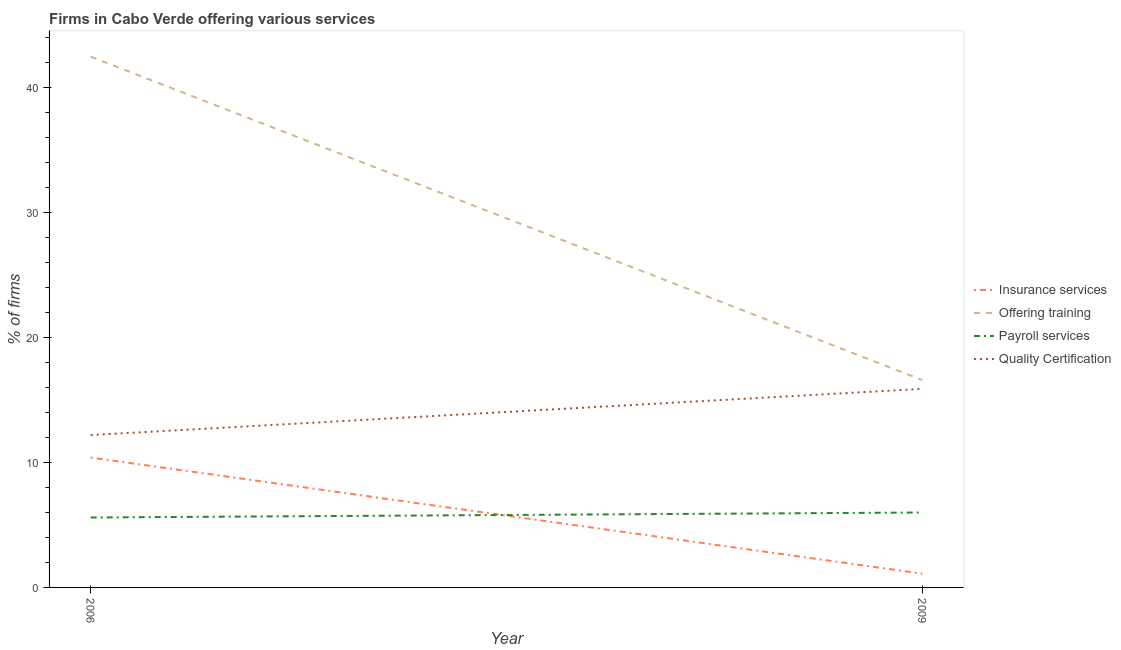Is the number of lines equal to the number of legend labels?
Make the answer very short. Yes. Across all years, what is the maximum percentage of firms offering training?
Give a very brief answer. 42.5. Across all years, what is the minimum percentage of firms offering quality certification?
Ensure brevity in your answer.  12.2. In which year was the percentage of firms offering payroll services maximum?
Your response must be concise. 2009. In which year was the percentage of firms offering payroll services minimum?
Offer a very short reply. 2006. What is the total percentage of firms offering insurance services in the graph?
Offer a very short reply. 11.5. What is the difference between the percentage of firms offering quality certification in 2006 and that in 2009?
Offer a very short reply. -3.7. What is the difference between the percentage of firms offering training in 2009 and the percentage of firms offering quality certification in 2006?
Your answer should be compact. 4.4. What is the average percentage of firms offering payroll services per year?
Make the answer very short. 5.8. In the year 2009, what is the difference between the percentage of firms offering training and percentage of firms offering payroll services?
Ensure brevity in your answer.  10.6. What is the ratio of the percentage of firms offering insurance services in 2006 to that in 2009?
Ensure brevity in your answer.  9.45. Is the percentage of firms offering quality certification in 2006 less than that in 2009?
Provide a succinct answer. Yes. Is it the case that in every year, the sum of the percentage of firms offering quality certification and percentage of firms offering insurance services is greater than the sum of percentage of firms offering training and percentage of firms offering payroll services?
Provide a short and direct response. No. Is it the case that in every year, the sum of the percentage of firms offering insurance services and percentage of firms offering training is greater than the percentage of firms offering payroll services?
Provide a short and direct response. Yes. Is the percentage of firms offering quality certification strictly greater than the percentage of firms offering training over the years?
Provide a succinct answer. No. How many years are there in the graph?
Provide a short and direct response. 2. Are the values on the major ticks of Y-axis written in scientific E-notation?
Your answer should be compact. No. What is the title of the graph?
Ensure brevity in your answer.  Firms in Cabo Verde offering various services . Does "Social equity" appear as one of the legend labels in the graph?
Your answer should be very brief. No. What is the label or title of the X-axis?
Your answer should be very brief. Year. What is the label or title of the Y-axis?
Make the answer very short. % of firms. What is the % of firms in Offering training in 2006?
Provide a succinct answer. 42.5. What is the % of firms in Quality Certification in 2009?
Give a very brief answer. 15.9. Across all years, what is the maximum % of firms in Insurance services?
Keep it short and to the point. 10.4. Across all years, what is the maximum % of firms of Offering training?
Ensure brevity in your answer.  42.5. Across all years, what is the maximum % of firms of Quality Certification?
Ensure brevity in your answer.  15.9. Across all years, what is the minimum % of firms of Insurance services?
Provide a succinct answer. 1.1. Across all years, what is the minimum % of firms of Offering training?
Give a very brief answer. 16.6. Across all years, what is the minimum % of firms in Quality Certification?
Give a very brief answer. 12.2. What is the total % of firms in Insurance services in the graph?
Your answer should be very brief. 11.5. What is the total % of firms of Offering training in the graph?
Offer a very short reply. 59.1. What is the total % of firms in Payroll services in the graph?
Provide a succinct answer. 11.6. What is the total % of firms in Quality Certification in the graph?
Offer a terse response. 28.1. What is the difference between the % of firms in Insurance services in 2006 and that in 2009?
Keep it short and to the point. 9.3. What is the difference between the % of firms of Offering training in 2006 and that in 2009?
Make the answer very short. 25.9. What is the difference between the % of firms in Payroll services in 2006 and that in 2009?
Your answer should be very brief. -0.4. What is the difference between the % of firms of Insurance services in 2006 and the % of firms of Quality Certification in 2009?
Provide a short and direct response. -5.5. What is the difference between the % of firms of Offering training in 2006 and the % of firms of Payroll services in 2009?
Your answer should be compact. 36.5. What is the difference between the % of firms of Offering training in 2006 and the % of firms of Quality Certification in 2009?
Provide a short and direct response. 26.6. What is the average % of firms of Insurance services per year?
Provide a short and direct response. 5.75. What is the average % of firms of Offering training per year?
Make the answer very short. 29.55. What is the average % of firms in Payroll services per year?
Provide a succinct answer. 5.8. What is the average % of firms in Quality Certification per year?
Your response must be concise. 14.05. In the year 2006, what is the difference between the % of firms in Insurance services and % of firms in Offering training?
Your answer should be very brief. -32.1. In the year 2006, what is the difference between the % of firms in Offering training and % of firms in Payroll services?
Provide a short and direct response. 36.9. In the year 2006, what is the difference between the % of firms in Offering training and % of firms in Quality Certification?
Offer a terse response. 30.3. In the year 2006, what is the difference between the % of firms in Payroll services and % of firms in Quality Certification?
Keep it short and to the point. -6.6. In the year 2009, what is the difference between the % of firms in Insurance services and % of firms in Offering training?
Give a very brief answer. -15.5. In the year 2009, what is the difference between the % of firms of Insurance services and % of firms of Payroll services?
Ensure brevity in your answer.  -4.9. In the year 2009, what is the difference between the % of firms in Insurance services and % of firms in Quality Certification?
Offer a terse response. -14.8. In the year 2009, what is the difference between the % of firms in Offering training and % of firms in Payroll services?
Ensure brevity in your answer.  10.6. In the year 2009, what is the difference between the % of firms of Offering training and % of firms of Quality Certification?
Give a very brief answer. 0.7. In the year 2009, what is the difference between the % of firms in Payroll services and % of firms in Quality Certification?
Offer a very short reply. -9.9. What is the ratio of the % of firms of Insurance services in 2006 to that in 2009?
Your answer should be compact. 9.45. What is the ratio of the % of firms of Offering training in 2006 to that in 2009?
Your answer should be compact. 2.56. What is the ratio of the % of firms in Quality Certification in 2006 to that in 2009?
Make the answer very short. 0.77. What is the difference between the highest and the second highest % of firms of Insurance services?
Ensure brevity in your answer.  9.3. What is the difference between the highest and the second highest % of firms in Offering training?
Give a very brief answer. 25.9. What is the difference between the highest and the second highest % of firms of Payroll services?
Your response must be concise. 0.4. What is the difference between the highest and the second highest % of firms in Quality Certification?
Ensure brevity in your answer.  3.7. What is the difference between the highest and the lowest % of firms in Offering training?
Make the answer very short. 25.9. 